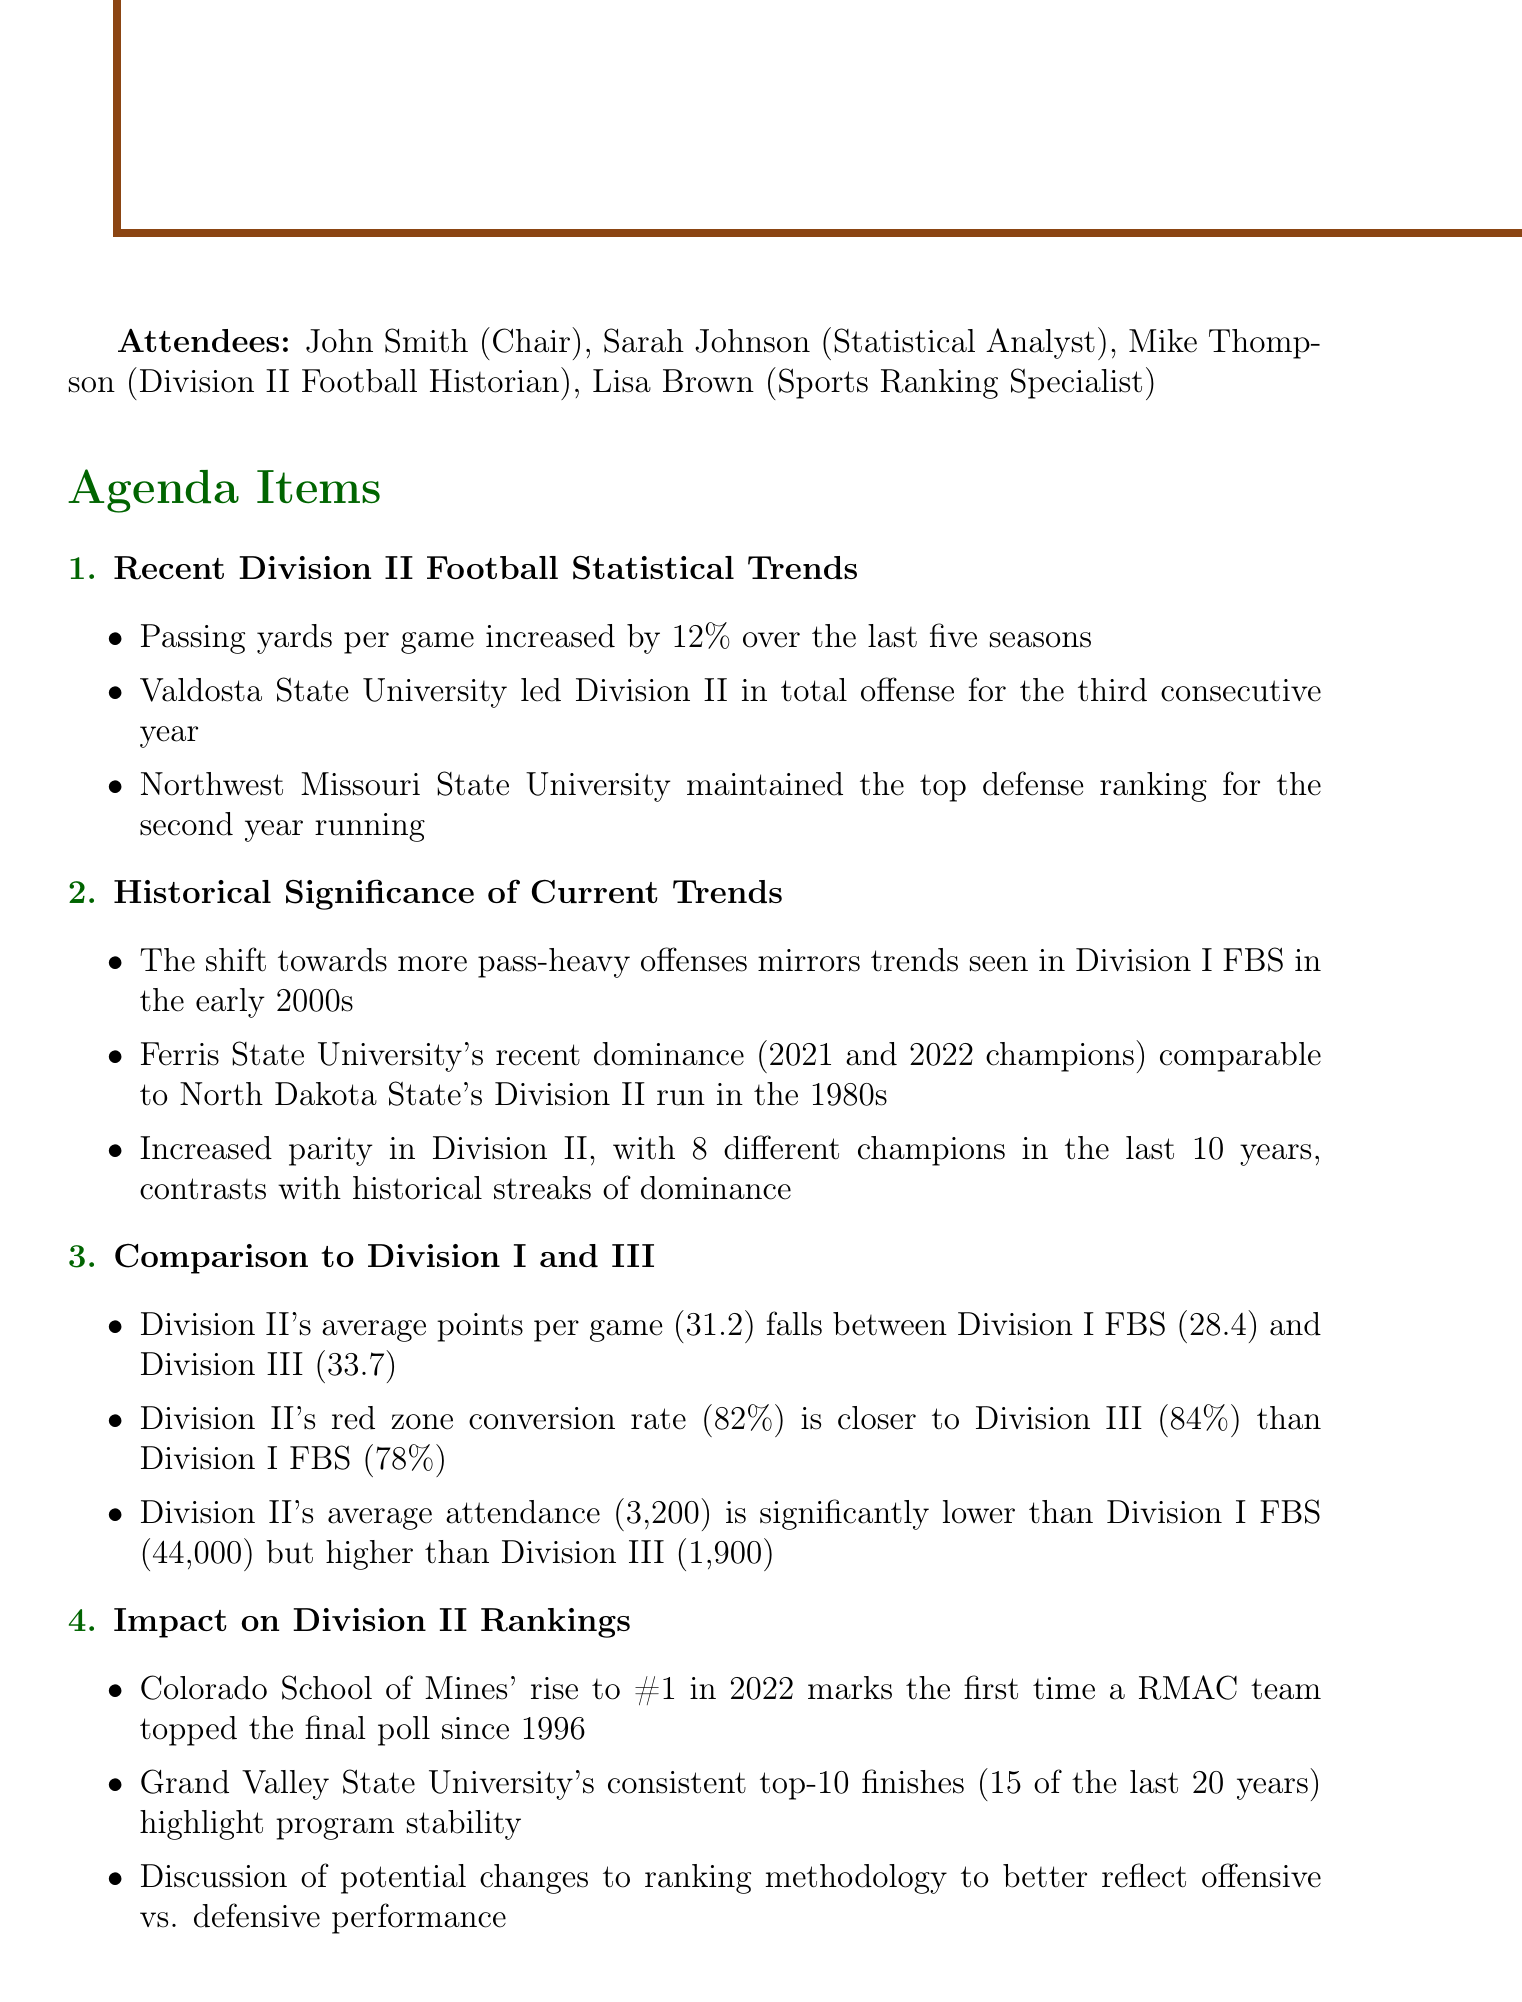What was the date of the meeting? The date of the meeting is stated in the document, which is May 15, 2023.
Answer: May 15, 2023 Who led Division II in total offense for three consecutive years? The document specifically mentions Valdosta State University as the leader in total offense for three years.
Answer: Valdosta State University What is the average attendance in Division II? The average attendance for Division II is outlined in the comparison with other divisions, which is 3,200.
Answer: 3,200 How many different champions have there been in the last 10 years in Division II? The document notes that there have been 8 different champions in the last 10 years.
Answer: 8 What new ranking did Colorado School of Mines achieve in 2022? The rise to rank #1 in 2022 for Colorado School of Mines is highlighted in the impact section.
Answer: #1 What is the red zone conversion rate for Division II? The document indicates that Division II's red zone conversion rate is 82%.
Answer: 82% Which teams' recent dominance is compared to North Dakota State's run in the 1980s? The discussion includes Ferris State University's championships in 2021 and 2022, which are compared to that historical run.
Answer: Ferris State University What is the main goal of the action item regarding passing yard trends? The action item mentions compiling a report on passing yard trends across all three divisions, focusing on a specific time frame.
Answer: Comprehensive report on passing yard trends What is a key topic discussed under the impact on Division II rankings? The discussion touches upon potential changes to ranking methodology to better reflect performance.
Answer: Changes to ranking methodology 